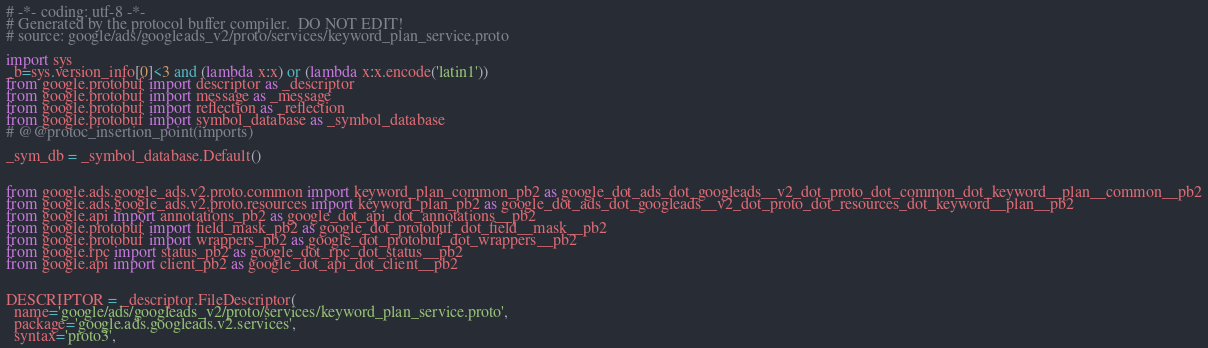<code> <loc_0><loc_0><loc_500><loc_500><_Python_># -*- coding: utf-8 -*-
# Generated by the protocol buffer compiler.  DO NOT EDIT!
# source: google/ads/googleads_v2/proto/services/keyword_plan_service.proto

import sys
_b=sys.version_info[0]<3 and (lambda x:x) or (lambda x:x.encode('latin1'))
from google.protobuf import descriptor as _descriptor
from google.protobuf import message as _message
from google.protobuf import reflection as _reflection
from google.protobuf import symbol_database as _symbol_database
# @@protoc_insertion_point(imports)

_sym_db = _symbol_database.Default()


from google.ads.google_ads.v2.proto.common import keyword_plan_common_pb2 as google_dot_ads_dot_googleads__v2_dot_proto_dot_common_dot_keyword__plan__common__pb2
from google.ads.google_ads.v2.proto.resources import keyword_plan_pb2 as google_dot_ads_dot_googleads__v2_dot_proto_dot_resources_dot_keyword__plan__pb2
from google.api import annotations_pb2 as google_dot_api_dot_annotations__pb2
from google.protobuf import field_mask_pb2 as google_dot_protobuf_dot_field__mask__pb2
from google.protobuf import wrappers_pb2 as google_dot_protobuf_dot_wrappers__pb2
from google.rpc import status_pb2 as google_dot_rpc_dot_status__pb2
from google.api import client_pb2 as google_dot_api_dot_client__pb2


DESCRIPTOR = _descriptor.FileDescriptor(
  name='google/ads/googleads_v2/proto/services/keyword_plan_service.proto',
  package='google.ads.googleads.v2.services',
  syntax='proto3',</code> 